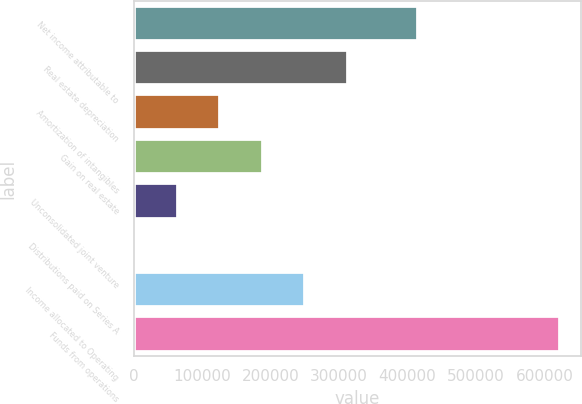<chart> <loc_0><loc_0><loc_500><loc_500><bar_chart><fcel>Net income attributable to<fcel>Real estate depreciation<fcel>Amortization of intangibles<fcel>Gain on real estate<fcel>Unconsolidated joint venture<fcel>Distributions paid on Series A<fcel>Income allocated to Operating<fcel>Funds from operations<nl><fcel>415289<fcel>312632<fcel>126426<fcel>188494<fcel>64356.8<fcel>2288<fcel>250563<fcel>622976<nl></chart> 